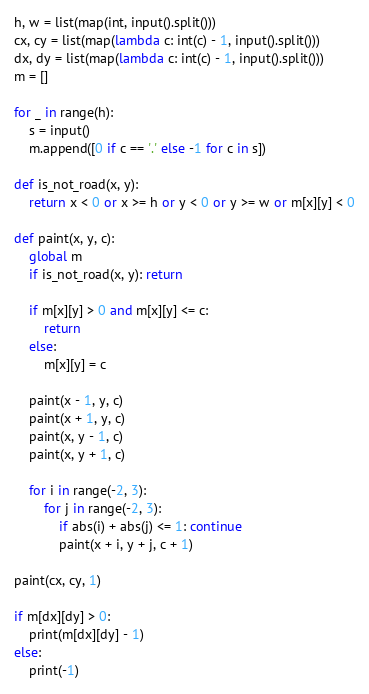<code> <loc_0><loc_0><loc_500><loc_500><_Python_>h, w = list(map(int, input().split()))
cx, cy = list(map(lambda c: int(c) - 1, input().split()))
dx, dy = list(map(lambda c: int(c) - 1, input().split()))
m = []

for _ in range(h):
    s = input()
    m.append([0 if c == '.' else -1 for c in s])

def is_not_road(x, y):
    return x < 0 or x >= h or y < 0 or y >= w or m[x][y] < 0

def paint(x, y, c):
    global m
    if is_not_road(x, y): return

    if m[x][y] > 0 and m[x][y] <= c:
        return
    else:
        m[x][y] = c

    paint(x - 1, y, c)
    paint(x + 1, y, c)
    paint(x, y - 1, c)
    paint(x, y + 1, c)

    for i in range(-2, 3):
        for j in range(-2, 3):
            if abs(i) + abs(j) <= 1: continue
            paint(x + i, y + j, c + 1)

paint(cx, cy, 1)

if m[dx][dy] > 0:
    print(m[dx][dy] - 1)
else:
    print(-1)</code> 